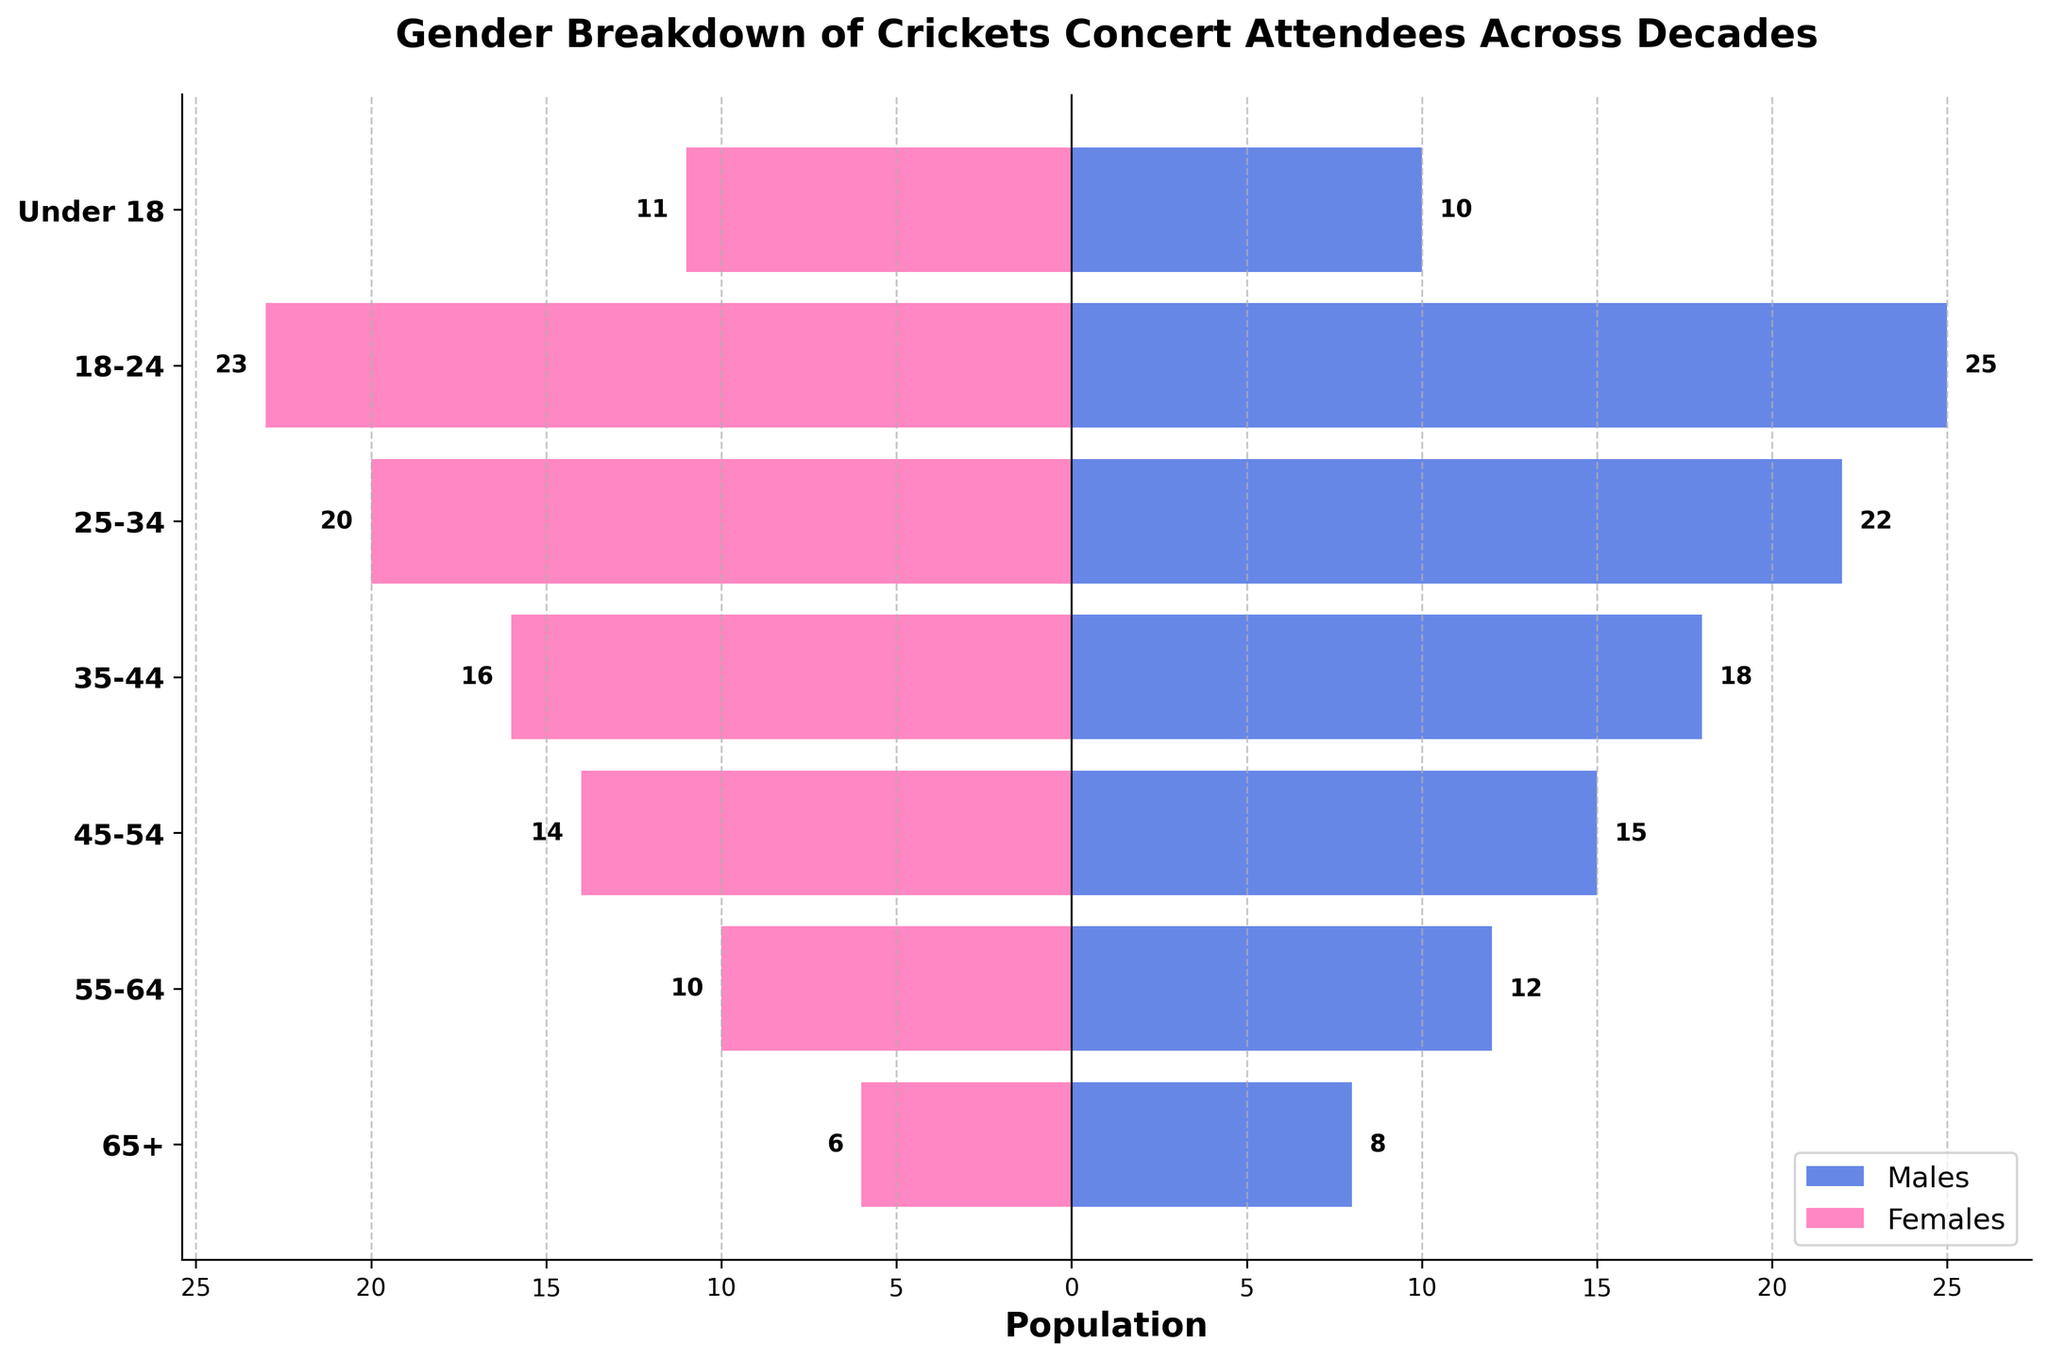What's the title of the chart? Look at the top of the chart where the title is typically placed. The title is prominently displayed and reads "Gender Breakdown of Crickets Concert Attendees Across Decades".
Answer: Gender Breakdown of Crickets Concert Attendees Across Decades What does the horizontal axis represent? Refer to the label on the horizontal axis. The horizontal axis is labeled with the word "Population".
Answer: Population Which age group has the highest number of male attendees? Check the length of the blue bars representing male attendees in different age groups. The age group with the highest number of male attendees has the longest blue bar. This is the "18-24" age group.
Answer: 18-24 Which age group has more female attendees than male attendees? Compare the lengths of the pink (female) bars and blue (male) bars across age groups. The "Under 18" age group has a longer pink bar compared to the blue bar.
Answer: Under 18 How many total attendees are there in the "35-44" age group? Add the number of male and female attendees in the "35-44" age group. Males: 18, Females: 16. So, 18 + 16 = 34.
Answer: 34 In which age group is the gender distribution most balanced? Find the age group where the absolute difference between the number of male and female attendees is the smallest. For the "45-54" age group, the numbers are 15 (males) and 14 (females), with a difference of 1, the smallest across all groups.
Answer: 45-54 What is the total population for attendees under the age of 18? Add the number of male and female attendees in the "Under 18" age group. Males: 10, Females: 11. So, 10 + 11 = 21.
Answer: 21 Which age group contains the least number of attendees overall? Look for the age group with the shortest combined bar lengths for both males and females. The "65+" age group has the combined length of 8 (males) + 6 (females) = 14.
Answer: 65+ How does the population of male attendees in the "25-34" age group compare to that of the female attendees? Compare the lengths of the blue bar and the pink bar for the "25-34" age group. Males have 22 attendees while females have 20, indicating there are more male attendees.
Answer: More males What proportion of the "18-24" age group attendees are females? Calculate the proportion of female attendees in the "18-24" age group. The total number of attendees in this group is 25 (males) + 23 (females) = 48. The proportion of females is 23/48 ≈ 0.479 or 47.9%.
Answer: 47.9% 